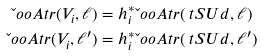Convert formula to latex. <formula><loc_0><loc_0><loc_500><loc_500>\L o o A t r ( V _ { i } , \ell ) & = h _ { i } ^ { * } \L o o A t r ( \ t S U d , \ell ) \\ \L o o A t r ( V _ { i } , \ell ^ { \prime } ) & = h _ { i } ^ { * } \L o o A t r ( \ t S U d , \ell ^ { \prime } )</formula> 